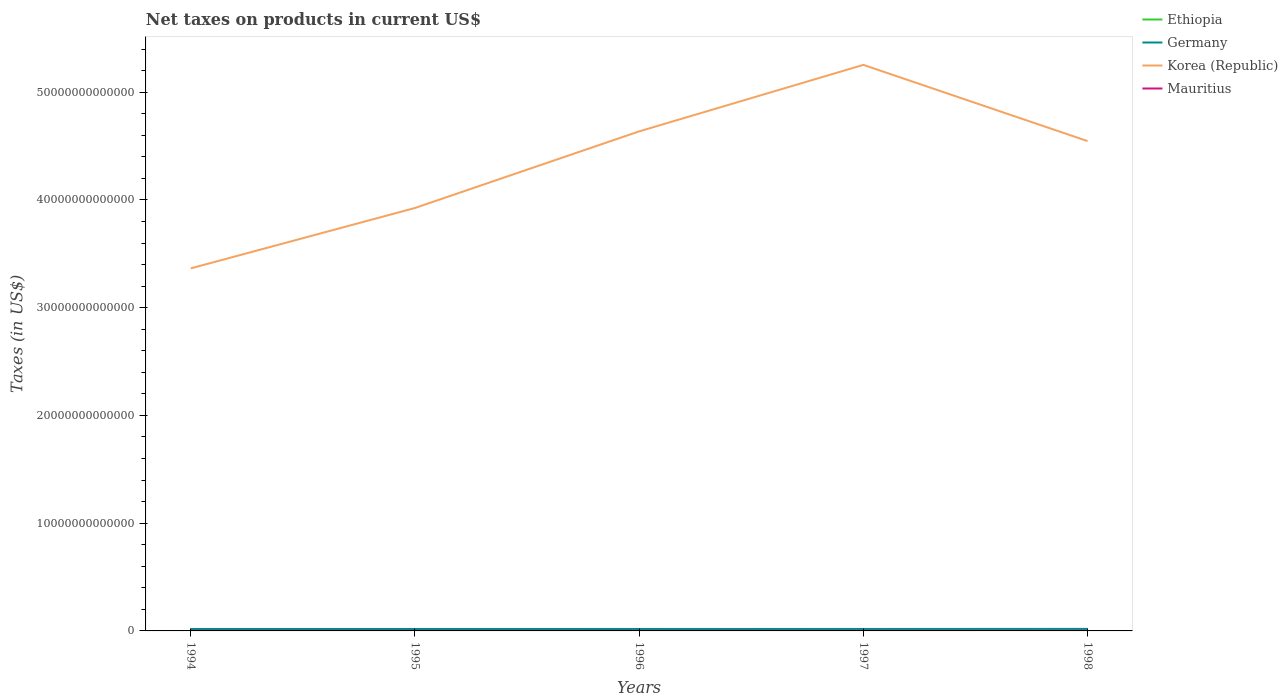How many different coloured lines are there?
Offer a very short reply. 4. Does the line corresponding to Ethiopia intersect with the line corresponding to Mauritius?
Provide a short and direct response. No. Across all years, what is the maximum net taxes on products in Ethiopia?
Provide a succinct answer. 2.13e+09. In which year was the net taxes on products in Ethiopia maximum?
Provide a short and direct response. 1994. What is the total net taxes on products in Korea (Republic) in the graph?
Keep it short and to the point. -1.27e+13. What is the difference between the highest and the second highest net taxes on products in Korea (Republic)?
Provide a short and direct response. 1.89e+13. What is the difference between the highest and the lowest net taxes on products in Germany?
Ensure brevity in your answer.  2. How many lines are there?
Offer a terse response. 4. How many years are there in the graph?
Offer a terse response. 5. What is the difference between two consecutive major ticks on the Y-axis?
Give a very brief answer. 1.00e+13. Are the values on the major ticks of Y-axis written in scientific E-notation?
Give a very brief answer. No. Does the graph contain any zero values?
Provide a succinct answer. No. Does the graph contain grids?
Your answer should be compact. No. How are the legend labels stacked?
Keep it short and to the point. Vertical. What is the title of the graph?
Offer a very short reply. Net taxes on products in current US$. Does "Central African Republic" appear as one of the legend labels in the graph?
Give a very brief answer. No. What is the label or title of the X-axis?
Your answer should be compact. Years. What is the label or title of the Y-axis?
Provide a succinct answer. Taxes (in US$). What is the Taxes (in US$) of Ethiopia in 1994?
Provide a short and direct response. 2.13e+09. What is the Taxes (in US$) in Germany in 1994?
Your answer should be very brief. 1.78e+11. What is the Taxes (in US$) of Korea (Republic) in 1994?
Your response must be concise. 3.37e+13. What is the Taxes (in US$) in Mauritius in 1994?
Give a very brief answer. 8.18e+09. What is the Taxes (in US$) of Ethiopia in 1995?
Ensure brevity in your answer.  2.71e+09. What is the Taxes (in US$) of Germany in 1995?
Keep it short and to the point. 1.78e+11. What is the Taxes (in US$) of Korea (Republic) in 1995?
Ensure brevity in your answer.  3.93e+13. What is the Taxes (in US$) in Mauritius in 1995?
Give a very brief answer. 7.99e+09. What is the Taxes (in US$) in Ethiopia in 1996?
Keep it short and to the point. 3.12e+09. What is the Taxes (in US$) in Germany in 1996?
Your answer should be compact. 1.80e+11. What is the Taxes (in US$) in Korea (Republic) in 1996?
Give a very brief answer. 4.64e+13. What is the Taxes (in US$) in Mauritius in 1996?
Ensure brevity in your answer.  8.77e+09. What is the Taxes (in US$) in Ethiopia in 1997?
Offer a terse response. 3.57e+09. What is the Taxes (in US$) of Germany in 1997?
Offer a terse response. 1.82e+11. What is the Taxes (in US$) of Korea (Republic) in 1997?
Offer a very short reply. 5.25e+13. What is the Taxes (in US$) of Mauritius in 1997?
Your answer should be compact. 1.05e+1. What is the Taxes (in US$) in Ethiopia in 1998?
Offer a very short reply. 3.51e+09. What is the Taxes (in US$) in Germany in 1998?
Your answer should be compact. 1.89e+11. What is the Taxes (in US$) in Korea (Republic) in 1998?
Provide a succinct answer. 4.55e+13. What is the Taxes (in US$) in Mauritius in 1998?
Offer a terse response. 1.22e+1. Across all years, what is the maximum Taxes (in US$) of Ethiopia?
Ensure brevity in your answer.  3.57e+09. Across all years, what is the maximum Taxes (in US$) in Germany?
Ensure brevity in your answer.  1.89e+11. Across all years, what is the maximum Taxes (in US$) of Korea (Republic)?
Keep it short and to the point. 5.25e+13. Across all years, what is the maximum Taxes (in US$) of Mauritius?
Offer a terse response. 1.22e+1. Across all years, what is the minimum Taxes (in US$) of Ethiopia?
Offer a terse response. 2.13e+09. Across all years, what is the minimum Taxes (in US$) in Germany?
Keep it short and to the point. 1.78e+11. Across all years, what is the minimum Taxes (in US$) of Korea (Republic)?
Make the answer very short. 3.37e+13. Across all years, what is the minimum Taxes (in US$) of Mauritius?
Make the answer very short. 7.99e+09. What is the total Taxes (in US$) in Ethiopia in the graph?
Make the answer very short. 1.50e+1. What is the total Taxes (in US$) of Germany in the graph?
Provide a succinct answer. 9.06e+11. What is the total Taxes (in US$) in Korea (Republic) in the graph?
Make the answer very short. 2.17e+14. What is the total Taxes (in US$) in Mauritius in the graph?
Give a very brief answer. 4.76e+1. What is the difference between the Taxes (in US$) in Ethiopia in 1994 and that in 1995?
Provide a short and direct response. -5.80e+08. What is the difference between the Taxes (in US$) of Germany in 1994 and that in 1995?
Your answer should be compact. -2.04e+08. What is the difference between the Taxes (in US$) in Korea (Republic) in 1994 and that in 1995?
Make the answer very short. -5.61e+12. What is the difference between the Taxes (in US$) in Mauritius in 1994 and that in 1995?
Offer a terse response. 1.91e+08. What is the difference between the Taxes (in US$) in Ethiopia in 1994 and that in 1996?
Offer a very short reply. -9.89e+08. What is the difference between the Taxes (in US$) of Germany in 1994 and that in 1996?
Offer a very short reply. -1.83e+09. What is the difference between the Taxes (in US$) in Korea (Republic) in 1994 and that in 1996?
Give a very brief answer. -1.27e+13. What is the difference between the Taxes (in US$) in Mauritius in 1994 and that in 1996?
Your answer should be compact. -5.90e+08. What is the difference between the Taxes (in US$) of Ethiopia in 1994 and that in 1997?
Keep it short and to the point. -1.44e+09. What is the difference between the Taxes (in US$) in Germany in 1994 and that in 1997?
Your response must be concise. -4.17e+09. What is the difference between the Taxes (in US$) in Korea (Republic) in 1994 and that in 1997?
Make the answer very short. -1.89e+13. What is the difference between the Taxes (in US$) of Mauritius in 1994 and that in 1997?
Your answer should be compact. -2.27e+09. What is the difference between the Taxes (in US$) of Ethiopia in 1994 and that in 1998?
Offer a terse response. -1.38e+09. What is the difference between the Taxes (in US$) of Germany in 1994 and that in 1998?
Give a very brief answer. -1.07e+1. What is the difference between the Taxes (in US$) of Korea (Republic) in 1994 and that in 1998?
Make the answer very short. -1.18e+13. What is the difference between the Taxes (in US$) in Mauritius in 1994 and that in 1998?
Provide a short and direct response. -4.03e+09. What is the difference between the Taxes (in US$) in Ethiopia in 1995 and that in 1996?
Give a very brief answer. -4.08e+08. What is the difference between the Taxes (in US$) of Germany in 1995 and that in 1996?
Keep it short and to the point. -1.62e+09. What is the difference between the Taxes (in US$) in Korea (Republic) in 1995 and that in 1996?
Make the answer very short. -7.11e+12. What is the difference between the Taxes (in US$) in Mauritius in 1995 and that in 1996?
Give a very brief answer. -7.81e+08. What is the difference between the Taxes (in US$) in Ethiopia in 1995 and that in 1997?
Make the answer very short. -8.61e+08. What is the difference between the Taxes (in US$) in Germany in 1995 and that in 1997?
Give a very brief answer. -3.96e+09. What is the difference between the Taxes (in US$) of Korea (Republic) in 1995 and that in 1997?
Offer a very short reply. -1.33e+13. What is the difference between the Taxes (in US$) in Mauritius in 1995 and that in 1997?
Ensure brevity in your answer.  -2.46e+09. What is the difference between the Taxes (in US$) of Ethiopia in 1995 and that in 1998?
Your answer should be compact. -8.01e+08. What is the difference between the Taxes (in US$) in Germany in 1995 and that in 1998?
Provide a short and direct response. -1.05e+1. What is the difference between the Taxes (in US$) in Korea (Republic) in 1995 and that in 1998?
Offer a terse response. -6.21e+12. What is the difference between the Taxes (in US$) in Mauritius in 1995 and that in 1998?
Keep it short and to the point. -4.22e+09. What is the difference between the Taxes (in US$) of Ethiopia in 1996 and that in 1997?
Provide a succinct answer. -4.52e+08. What is the difference between the Taxes (in US$) in Germany in 1996 and that in 1997?
Offer a terse response. -2.34e+09. What is the difference between the Taxes (in US$) of Korea (Republic) in 1996 and that in 1997?
Your response must be concise. -6.17e+12. What is the difference between the Taxes (in US$) in Mauritius in 1996 and that in 1997?
Keep it short and to the point. -1.68e+09. What is the difference between the Taxes (in US$) in Ethiopia in 1996 and that in 1998?
Ensure brevity in your answer.  -3.92e+08. What is the difference between the Taxes (in US$) in Germany in 1996 and that in 1998?
Offer a very short reply. -8.86e+09. What is the difference between the Taxes (in US$) of Korea (Republic) in 1996 and that in 1998?
Keep it short and to the point. 9.02e+11. What is the difference between the Taxes (in US$) in Mauritius in 1996 and that in 1998?
Provide a succinct answer. -3.44e+09. What is the difference between the Taxes (in US$) of Ethiopia in 1997 and that in 1998?
Keep it short and to the point. 5.98e+07. What is the difference between the Taxes (in US$) in Germany in 1997 and that in 1998?
Your response must be concise. -6.52e+09. What is the difference between the Taxes (in US$) of Korea (Republic) in 1997 and that in 1998?
Make the answer very short. 7.07e+12. What is the difference between the Taxes (in US$) in Mauritius in 1997 and that in 1998?
Give a very brief answer. -1.75e+09. What is the difference between the Taxes (in US$) in Ethiopia in 1994 and the Taxes (in US$) in Germany in 1995?
Your answer should be compact. -1.76e+11. What is the difference between the Taxes (in US$) in Ethiopia in 1994 and the Taxes (in US$) in Korea (Republic) in 1995?
Offer a very short reply. -3.93e+13. What is the difference between the Taxes (in US$) of Ethiopia in 1994 and the Taxes (in US$) of Mauritius in 1995?
Your answer should be compact. -5.86e+09. What is the difference between the Taxes (in US$) in Germany in 1994 and the Taxes (in US$) in Korea (Republic) in 1995?
Offer a very short reply. -3.91e+13. What is the difference between the Taxes (in US$) of Germany in 1994 and the Taxes (in US$) of Mauritius in 1995?
Make the answer very short. 1.70e+11. What is the difference between the Taxes (in US$) of Korea (Republic) in 1994 and the Taxes (in US$) of Mauritius in 1995?
Provide a short and direct response. 3.36e+13. What is the difference between the Taxes (in US$) in Ethiopia in 1994 and the Taxes (in US$) in Germany in 1996?
Your answer should be very brief. -1.78e+11. What is the difference between the Taxes (in US$) of Ethiopia in 1994 and the Taxes (in US$) of Korea (Republic) in 1996?
Make the answer very short. -4.64e+13. What is the difference between the Taxes (in US$) in Ethiopia in 1994 and the Taxes (in US$) in Mauritius in 1996?
Provide a succinct answer. -6.64e+09. What is the difference between the Taxes (in US$) of Germany in 1994 and the Taxes (in US$) of Korea (Republic) in 1996?
Your answer should be very brief. -4.62e+13. What is the difference between the Taxes (in US$) in Germany in 1994 and the Taxes (in US$) in Mauritius in 1996?
Your answer should be compact. 1.69e+11. What is the difference between the Taxes (in US$) of Korea (Republic) in 1994 and the Taxes (in US$) of Mauritius in 1996?
Your response must be concise. 3.36e+13. What is the difference between the Taxes (in US$) of Ethiopia in 1994 and the Taxes (in US$) of Germany in 1997?
Your response must be concise. -1.80e+11. What is the difference between the Taxes (in US$) in Ethiopia in 1994 and the Taxes (in US$) in Korea (Republic) in 1997?
Your answer should be compact. -5.25e+13. What is the difference between the Taxes (in US$) of Ethiopia in 1994 and the Taxes (in US$) of Mauritius in 1997?
Your response must be concise. -8.32e+09. What is the difference between the Taxes (in US$) of Germany in 1994 and the Taxes (in US$) of Korea (Republic) in 1997?
Keep it short and to the point. -5.24e+13. What is the difference between the Taxes (in US$) in Germany in 1994 and the Taxes (in US$) in Mauritius in 1997?
Your answer should be very brief. 1.67e+11. What is the difference between the Taxes (in US$) in Korea (Republic) in 1994 and the Taxes (in US$) in Mauritius in 1997?
Provide a short and direct response. 3.36e+13. What is the difference between the Taxes (in US$) in Ethiopia in 1994 and the Taxes (in US$) in Germany in 1998?
Give a very brief answer. -1.86e+11. What is the difference between the Taxes (in US$) in Ethiopia in 1994 and the Taxes (in US$) in Korea (Republic) in 1998?
Ensure brevity in your answer.  -4.55e+13. What is the difference between the Taxes (in US$) in Ethiopia in 1994 and the Taxes (in US$) in Mauritius in 1998?
Your answer should be compact. -1.01e+1. What is the difference between the Taxes (in US$) of Germany in 1994 and the Taxes (in US$) of Korea (Republic) in 1998?
Your response must be concise. -4.53e+13. What is the difference between the Taxes (in US$) in Germany in 1994 and the Taxes (in US$) in Mauritius in 1998?
Your answer should be very brief. 1.66e+11. What is the difference between the Taxes (in US$) of Korea (Republic) in 1994 and the Taxes (in US$) of Mauritius in 1998?
Provide a short and direct response. 3.36e+13. What is the difference between the Taxes (in US$) in Ethiopia in 1995 and the Taxes (in US$) in Germany in 1996?
Your answer should be compact. -1.77e+11. What is the difference between the Taxes (in US$) of Ethiopia in 1995 and the Taxes (in US$) of Korea (Republic) in 1996?
Offer a very short reply. -4.64e+13. What is the difference between the Taxes (in US$) in Ethiopia in 1995 and the Taxes (in US$) in Mauritius in 1996?
Your answer should be compact. -6.06e+09. What is the difference between the Taxes (in US$) in Germany in 1995 and the Taxes (in US$) in Korea (Republic) in 1996?
Your answer should be compact. -4.62e+13. What is the difference between the Taxes (in US$) in Germany in 1995 and the Taxes (in US$) in Mauritius in 1996?
Offer a very short reply. 1.69e+11. What is the difference between the Taxes (in US$) of Korea (Republic) in 1995 and the Taxes (in US$) of Mauritius in 1996?
Your response must be concise. 3.92e+13. What is the difference between the Taxes (in US$) in Ethiopia in 1995 and the Taxes (in US$) in Germany in 1997?
Ensure brevity in your answer.  -1.79e+11. What is the difference between the Taxes (in US$) in Ethiopia in 1995 and the Taxes (in US$) in Korea (Republic) in 1997?
Offer a terse response. -5.25e+13. What is the difference between the Taxes (in US$) in Ethiopia in 1995 and the Taxes (in US$) in Mauritius in 1997?
Provide a short and direct response. -7.74e+09. What is the difference between the Taxes (in US$) in Germany in 1995 and the Taxes (in US$) in Korea (Republic) in 1997?
Make the answer very short. -5.24e+13. What is the difference between the Taxes (in US$) in Germany in 1995 and the Taxes (in US$) in Mauritius in 1997?
Provide a succinct answer. 1.68e+11. What is the difference between the Taxes (in US$) of Korea (Republic) in 1995 and the Taxes (in US$) of Mauritius in 1997?
Give a very brief answer. 3.92e+13. What is the difference between the Taxes (in US$) of Ethiopia in 1995 and the Taxes (in US$) of Germany in 1998?
Give a very brief answer. -1.86e+11. What is the difference between the Taxes (in US$) of Ethiopia in 1995 and the Taxes (in US$) of Korea (Republic) in 1998?
Keep it short and to the point. -4.55e+13. What is the difference between the Taxes (in US$) of Ethiopia in 1995 and the Taxes (in US$) of Mauritius in 1998?
Offer a terse response. -9.49e+09. What is the difference between the Taxes (in US$) in Germany in 1995 and the Taxes (in US$) in Korea (Republic) in 1998?
Your answer should be very brief. -4.53e+13. What is the difference between the Taxes (in US$) in Germany in 1995 and the Taxes (in US$) in Mauritius in 1998?
Provide a short and direct response. 1.66e+11. What is the difference between the Taxes (in US$) of Korea (Republic) in 1995 and the Taxes (in US$) of Mauritius in 1998?
Give a very brief answer. 3.92e+13. What is the difference between the Taxes (in US$) in Ethiopia in 1996 and the Taxes (in US$) in Germany in 1997?
Offer a very short reply. -1.79e+11. What is the difference between the Taxes (in US$) in Ethiopia in 1996 and the Taxes (in US$) in Korea (Republic) in 1997?
Make the answer very short. -5.25e+13. What is the difference between the Taxes (in US$) in Ethiopia in 1996 and the Taxes (in US$) in Mauritius in 1997?
Keep it short and to the point. -7.33e+09. What is the difference between the Taxes (in US$) in Germany in 1996 and the Taxes (in US$) in Korea (Republic) in 1997?
Make the answer very short. -5.24e+13. What is the difference between the Taxes (in US$) of Germany in 1996 and the Taxes (in US$) of Mauritius in 1997?
Give a very brief answer. 1.69e+11. What is the difference between the Taxes (in US$) of Korea (Republic) in 1996 and the Taxes (in US$) of Mauritius in 1997?
Offer a terse response. 4.64e+13. What is the difference between the Taxes (in US$) in Ethiopia in 1996 and the Taxes (in US$) in Germany in 1998?
Make the answer very short. -1.85e+11. What is the difference between the Taxes (in US$) of Ethiopia in 1996 and the Taxes (in US$) of Korea (Republic) in 1998?
Give a very brief answer. -4.55e+13. What is the difference between the Taxes (in US$) in Ethiopia in 1996 and the Taxes (in US$) in Mauritius in 1998?
Offer a terse response. -9.09e+09. What is the difference between the Taxes (in US$) in Germany in 1996 and the Taxes (in US$) in Korea (Republic) in 1998?
Offer a terse response. -4.53e+13. What is the difference between the Taxes (in US$) of Germany in 1996 and the Taxes (in US$) of Mauritius in 1998?
Provide a succinct answer. 1.68e+11. What is the difference between the Taxes (in US$) of Korea (Republic) in 1996 and the Taxes (in US$) of Mauritius in 1998?
Your answer should be compact. 4.64e+13. What is the difference between the Taxes (in US$) of Ethiopia in 1997 and the Taxes (in US$) of Germany in 1998?
Your answer should be compact. -1.85e+11. What is the difference between the Taxes (in US$) in Ethiopia in 1997 and the Taxes (in US$) in Korea (Republic) in 1998?
Make the answer very short. -4.55e+13. What is the difference between the Taxes (in US$) in Ethiopia in 1997 and the Taxes (in US$) in Mauritius in 1998?
Your answer should be very brief. -8.63e+09. What is the difference between the Taxes (in US$) in Germany in 1997 and the Taxes (in US$) in Korea (Republic) in 1998?
Ensure brevity in your answer.  -4.53e+13. What is the difference between the Taxes (in US$) of Germany in 1997 and the Taxes (in US$) of Mauritius in 1998?
Make the answer very short. 1.70e+11. What is the difference between the Taxes (in US$) of Korea (Republic) in 1997 and the Taxes (in US$) of Mauritius in 1998?
Your response must be concise. 5.25e+13. What is the average Taxes (in US$) in Ethiopia per year?
Offer a very short reply. 3.01e+09. What is the average Taxes (in US$) of Germany per year?
Offer a very short reply. 1.81e+11. What is the average Taxes (in US$) in Korea (Republic) per year?
Offer a terse response. 4.35e+13. What is the average Taxes (in US$) of Mauritius per year?
Keep it short and to the point. 9.52e+09. In the year 1994, what is the difference between the Taxes (in US$) of Ethiopia and Taxes (in US$) of Germany?
Provide a succinct answer. -1.76e+11. In the year 1994, what is the difference between the Taxes (in US$) of Ethiopia and Taxes (in US$) of Korea (Republic)?
Keep it short and to the point. -3.36e+13. In the year 1994, what is the difference between the Taxes (in US$) in Ethiopia and Taxes (in US$) in Mauritius?
Your answer should be very brief. -6.05e+09. In the year 1994, what is the difference between the Taxes (in US$) of Germany and Taxes (in US$) of Korea (Republic)?
Provide a succinct answer. -3.35e+13. In the year 1994, what is the difference between the Taxes (in US$) in Germany and Taxes (in US$) in Mauritius?
Give a very brief answer. 1.70e+11. In the year 1994, what is the difference between the Taxes (in US$) of Korea (Republic) and Taxes (in US$) of Mauritius?
Ensure brevity in your answer.  3.36e+13. In the year 1995, what is the difference between the Taxes (in US$) in Ethiopia and Taxes (in US$) in Germany?
Provide a succinct answer. -1.75e+11. In the year 1995, what is the difference between the Taxes (in US$) of Ethiopia and Taxes (in US$) of Korea (Republic)?
Your answer should be compact. -3.93e+13. In the year 1995, what is the difference between the Taxes (in US$) of Ethiopia and Taxes (in US$) of Mauritius?
Keep it short and to the point. -5.28e+09. In the year 1995, what is the difference between the Taxes (in US$) in Germany and Taxes (in US$) in Korea (Republic)?
Provide a succinct answer. -3.91e+13. In the year 1995, what is the difference between the Taxes (in US$) of Germany and Taxes (in US$) of Mauritius?
Provide a short and direct response. 1.70e+11. In the year 1995, what is the difference between the Taxes (in US$) of Korea (Republic) and Taxes (in US$) of Mauritius?
Offer a terse response. 3.92e+13. In the year 1996, what is the difference between the Taxes (in US$) of Ethiopia and Taxes (in US$) of Germany?
Keep it short and to the point. -1.77e+11. In the year 1996, what is the difference between the Taxes (in US$) in Ethiopia and Taxes (in US$) in Korea (Republic)?
Ensure brevity in your answer.  -4.64e+13. In the year 1996, what is the difference between the Taxes (in US$) of Ethiopia and Taxes (in US$) of Mauritius?
Your response must be concise. -5.65e+09. In the year 1996, what is the difference between the Taxes (in US$) in Germany and Taxes (in US$) in Korea (Republic)?
Offer a very short reply. -4.62e+13. In the year 1996, what is the difference between the Taxes (in US$) in Germany and Taxes (in US$) in Mauritius?
Provide a succinct answer. 1.71e+11. In the year 1996, what is the difference between the Taxes (in US$) of Korea (Republic) and Taxes (in US$) of Mauritius?
Your answer should be very brief. 4.64e+13. In the year 1997, what is the difference between the Taxes (in US$) in Ethiopia and Taxes (in US$) in Germany?
Give a very brief answer. -1.78e+11. In the year 1997, what is the difference between the Taxes (in US$) of Ethiopia and Taxes (in US$) of Korea (Republic)?
Your response must be concise. -5.25e+13. In the year 1997, what is the difference between the Taxes (in US$) in Ethiopia and Taxes (in US$) in Mauritius?
Your response must be concise. -6.88e+09. In the year 1997, what is the difference between the Taxes (in US$) of Germany and Taxes (in US$) of Korea (Republic)?
Offer a very short reply. -5.24e+13. In the year 1997, what is the difference between the Taxes (in US$) of Germany and Taxes (in US$) of Mauritius?
Your response must be concise. 1.72e+11. In the year 1997, what is the difference between the Taxes (in US$) of Korea (Republic) and Taxes (in US$) of Mauritius?
Keep it short and to the point. 5.25e+13. In the year 1998, what is the difference between the Taxes (in US$) of Ethiopia and Taxes (in US$) of Germany?
Ensure brevity in your answer.  -1.85e+11. In the year 1998, what is the difference between the Taxes (in US$) of Ethiopia and Taxes (in US$) of Korea (Republic)?
Provide a succinct answer. -4.55e+13. In the year 1998, what is the difference between the Taxes (in US$) of Ethiopia and Taxes (in US$) of Mauritius?
Your answer should be compact. -8.69e+09. In the year 1998, what is the difference between the Taxes (in US$) of Germany and Taxes (in US$) of Korea (Republic)?
Your answer should be compact. -4.53e+13. In the year 1998, what is the difference between the Taxes (in US$) in Germany and Taxes (in US$) in Mauritius?
Make the answer very short. 1.76e+11. In the year 1998, what is the difference between the Taxes (in US$) of Korea (Republic) and Taxes (in US$) of Mauritius?
Provide a short and direct response. 4.55e+13. What is the ratio of the Taxes (in US$) in Ethiopia in 1994 to that in 1995?
Make the answer very short. 0.79. What is the ratio of the Taxes (in US$) in Germany in 1994 to that in 1995?
Your answer should be compact. 1. What is the ratio of the Taxes (in US$) in Korea (Republic) in 1994 to that in 1995?
Your response must be concise. 0.86. What is the ratio of the Taxes (in US$) of Mauritius in 1994 to that in 1995?
Your response must be concise. 1.02. What is the ratio of the Taxes (in US$) of Ethiopia in 1994 to that in 1996?
Offer a terse response. 0.68. What is the ratio of the Taxes (in US$) in Germany in 1994 to that in 1996?
Your response must be concise. 0.99. What is the ratio of the Taxes (in US$) in Korea (Republic) in 1994 to that in 1996?
Your answer should be very brief. 0.73. What is the ratio of the Taxes (in US$) in Mauritius in 1994 to that in 1996?
Provide a succinct answer. 0.93. What is the ratio of the Taxes (in US$) of Ethiopia in 1994 to that in 1997?
Your answer should be very brief. 0.6. What is the ratio of the Taxes (in US$) in Germany in 1994 to that in 1997?
Your answer should be compact. 0.98. What is the ratio of the Taxes (in US$) of Korea (Republic) in 1994 to that in 1997?
Provide a short and direct response. 0.64. What is the ratio of the Taxes (in US$) of Mauritius in 1994 to that in 1997?
Provide a short and direct response. 0.78. What is the ratio of the Taxes (in US$) in Ethiopia in 1994 to that in 1998?
Give a very brief answer. 0.61. What is the ratio of the Taxes (in US$) of Germany in 1994 to that in 1998?
Keep it short and to the point. 0.94. What is the ratio of the Taxes (in US$) in Korea (Republic) in 1994 to that in 1998?
Your response must be concise. 0.74. What is the ratio of the Taxes (in US$) in Mauritius in 1994 to that in 1998?
Provide a succinct answer. 0.67. What is the ratio of the Taxes (in US$) of Ethiopia in 1995 to that in 1996?
Ensure brevity in your answer.  0.87. What is the ratio of the Taxes (in US$) in Korea (Republic) in 1995 to that in 1996?
Keep it short and to the point. 0.85. What is the ratio of the Taxes (in US$) in Mauritius in 1995 to that in 1996?
Provide a succinct answer. 0.91. What is the ratio of the Taxes (in US$) of Ethiopia in 1995 to that in 1997?
Your answer should be compact. 0.76. What is the ratio of the Taxes (in US$) of Germany in 1995 to that in 1997?
Offer a terse response. 0.98. What is the ratio of the Taxes (in US$) in Korea (Republic) in 1995 to that in 1997?
Your response must be concise. 0.75. What is the ratio of the Taxes (in US$) of Mauritius in 1995 to that in 1997?
Your response must be concise. 0.76. What is the ratio of the Taxes (in US$) of Ethiopia in 1995 to that in 1998?
Your answer should be very brief. 0.77. What is the ratio of the Taxes (in US$) of Korea (Republic) in 1995 to that in 1998?
Offer a terse response. 0.86. What is the ratio of the Taxes (in US$) of Mauritius in 1995 to that in 1998?
Your answer should be very brief. 0.65. What is the ratio of the Taxes (in US$) of Ethiopia in 1996 to that in 1997?
Provide a short and direct response. 0.87. What is the ratio of the Taxes (in US$) in Germany in 1996 to that in 1997?
Keep it short and to the point. 0.99. What is the ratio of the Taxes (in US$) of Korea (Republic) in 1996 to that in 1997?
Give a very brief answer. 0.88. What is the ratio of the Taxes (in US$) in Mauritius in 1996 to that in 1997?
Offer a very short reply. 0.84. What is the ratio of the Taxes (in US$) in Ethiopia in 1996 to that in 1998?
Your answer should be compact. 0.89. What is the ratio of the Taxes (in US$) in Germany in 1996 to that in 1998?
Your answer should be very brief. 0.95. What is the ratio of the Taxes (in US$) in Korea (Republic) in 1996 to that in 1998?
Your answer should be compact. 1.02. What is the ratio of the Taxes (in US$) in Mauritius in 1996 to that in 1998?
Ensure brevity in your answer.  0.72. What is the ratio of the Taxes (in US$) in Ethiopia in 1997 to that in 1998?
Keep it short and to the point. 1.02. What is the ratio of the Taxes (in US$) in Germany in 1997 to that in 1998?
Make the answer very short. 0.97. What is the ratio of the Taxes (in US$) of Korea (Republic) in 1997 to that in 1998?
Make the answer very short. 1.16. What is the ratio of the Taxes (in US$) of Mauritius in 1997 to that in 1998?
Offer a very short reply. 0.86. What is the difference between the highest and the second highest Taxes (in US$) of Ethiopia?
Ensure brevity in your answer.  5.98e+07. What is the difference between the highest and the second highest Taxes (in US$) of Germany?
Your answer should be very brief. 6.52e+09. What is the difference between the highest and the second highest Taxes (in US$) of Korea (Republic)?
Give a very brief answer. 6.17e+12. What is the difference between the highest and the second highest Taxes (in US$) in Mauritius?
Your answer should be very brief. 1.75e+09. What is the difference between the highest and the lowest Taxes (in US$) in Ethiopia?
Give a very brief answer. 1.44e+09. What is the difference between the highest and the lowest Taxes (in US$) of Germany?
Keep it short and to the point. 1.07e+1. What is the difference between the highest and the lowest Taxes (in US$) of Korea (Republic)?
Make the answer very short. 1.89e+13. What is the difference between the highest and the lowest Taxes (in US$) in Mauritius?
Your answer should be very brief. 4.22e+09. 